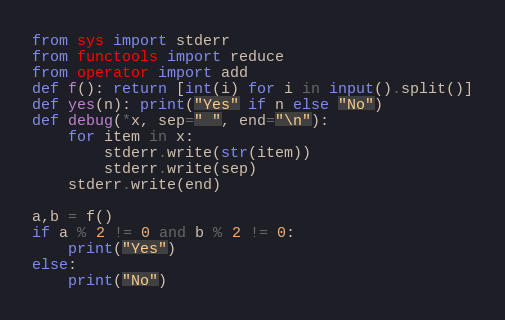<code> <loc_0><loc_0><loc_500><loc_500><_Python_>from sys import stderr
from functools import reduce
from operator import add
def f(): return [int(i) for i in input().split()]
def yes(n): print("Yes" if n else "No")
def debug(*x, sep=" ", end="\n"):
    for item in x:
        stderr.write(str(item))
        stderr.write(sep)
    stderr.write(end)

a,b = f()
if a % 2 != 0 and b % 2 != 0:
    print("Yes")
else:
    print("No")</code> 